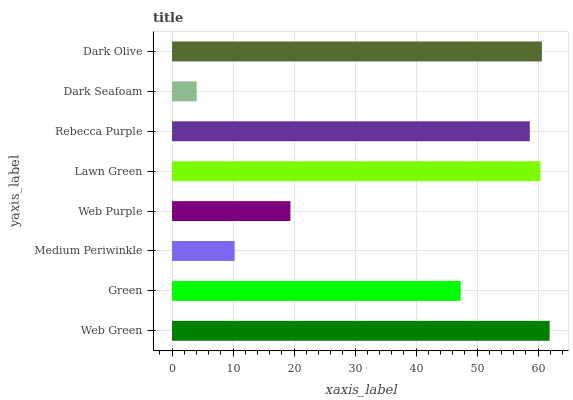Is Dark Seafoam the minimum?
Answer yes or no. Yes. Is Web Green the maximum?
Answer yes or no. Yes. Is Green the minimum?
Answer yes or no. No. Is Green the maximum?
Answer yes or no. No. Is Web Green greater than Green?
Answer yes or no. Yes. Is Green less than Web Green?
Answer yes or no. Yes. Is Green greater than Web Green?
Answer yes or no. No. Is Web Green less than Green?
Answer yes or no. No. Is Rebecca Purple the high median?
Answer yes or no. Yes. Is Green the low median?
Answer yes or no. Yes. Is Web Purple the high median?
Answer yes or no. No. Is Lawn Green the low median?
Answer yes or no. No. 